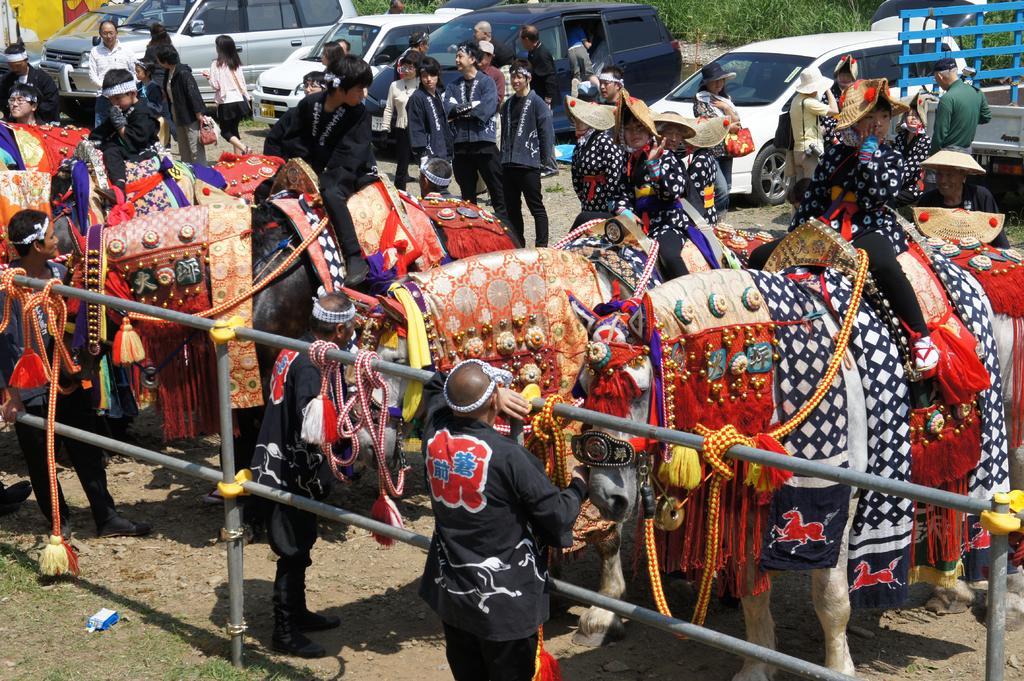In one or two sentences, can you explain what this image depicts? In the picture we can see some horses with a costume and some children sitting on the horses and the horses are tied to the railing and with some persons standing and in the background, we can see some people are standing and some cars are parked and behind it we can see some plants. 